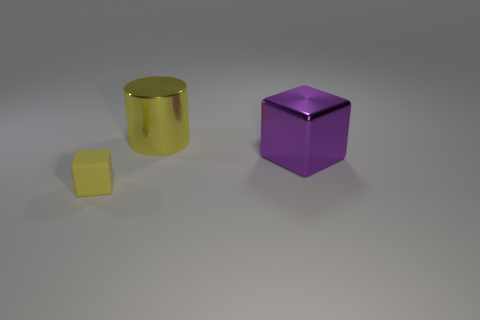Subtract all cylinders. How many objects are left? 2 Add 2 tiny yellow blocks. How many objects exist? 5 Add 1 blocks. How many blocks are left? 3 Add 2 rubber objects. How many rubber objects exist? 3 Subtract 0 gray cubes. How many objects are left? 3 Subtract all tiny matte objects. Subtract all big purple cubes. How many objects are left? 1 